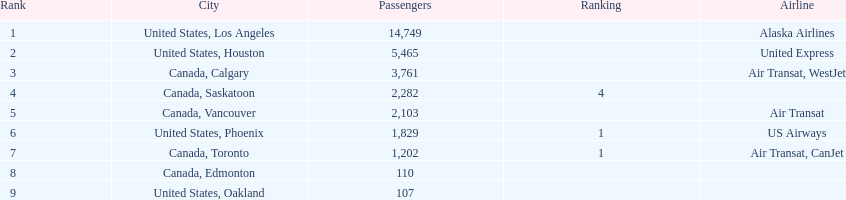Which airline has the highest number of passengers? Alaska Airlines. 